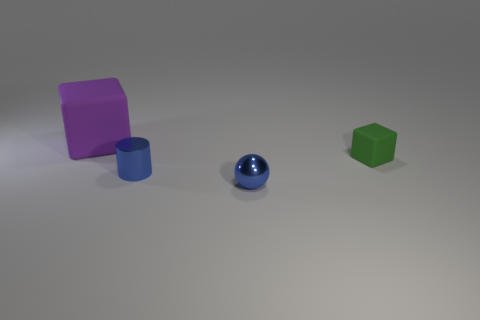Add 2 blue balls. How many objects exist? 6 Subtract all cylinders. How many objects are left? 3 Add 3 rubber blocks. How many rubber blocks exist? 5 Subtract 0 green cylinders. How many objects are left? 4 Subtract all tiny red metal blocks. Subtract all purple blocks. How many objects are left? 3 Add 2 tiny blue cylinders. How many tiny blue cylinders are left? 3 